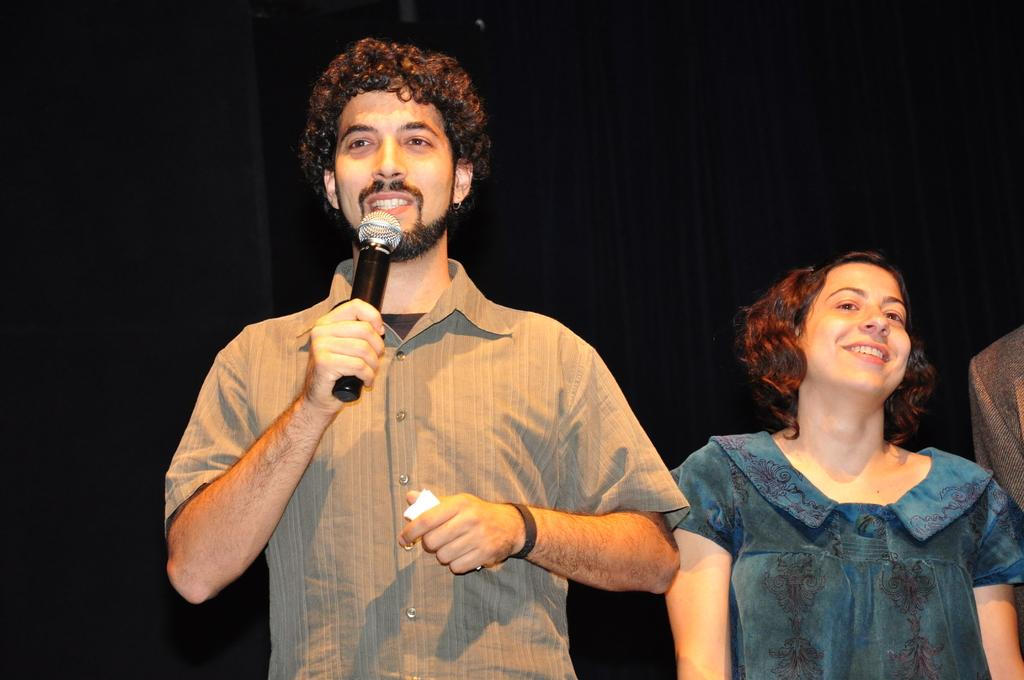Who is the main subject in the image? There is a man in the center of the image. What is the man holding in the image? The man is holding a microphone. Can you describe the lady beside the man? The lady is beside the man, and she is smiling. What type of leather is being used to make the snails in the image? There are no snails or leather present in the image. How many islands can be seen in the background of the image? There are no islands visible in the image. 